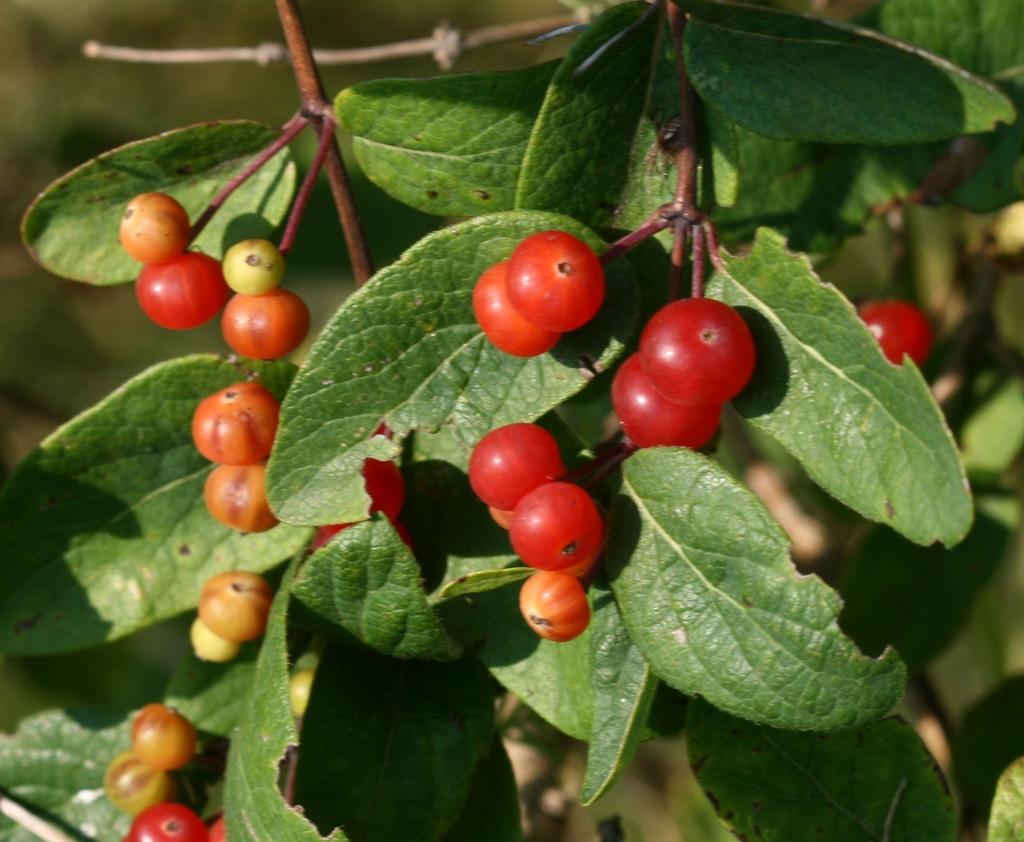What type of food items can be seen in the image? There are fruits in the image. What else is present in the image besides the fruits? There are leaves on stems in the image. How would you describe the overall clarity of the image? The image is slightly blurred in the background. How many ghosts are visible in the image? There are no ghosts present in the image. What type of boats can be seen in the image? There are no boats present in the image. 